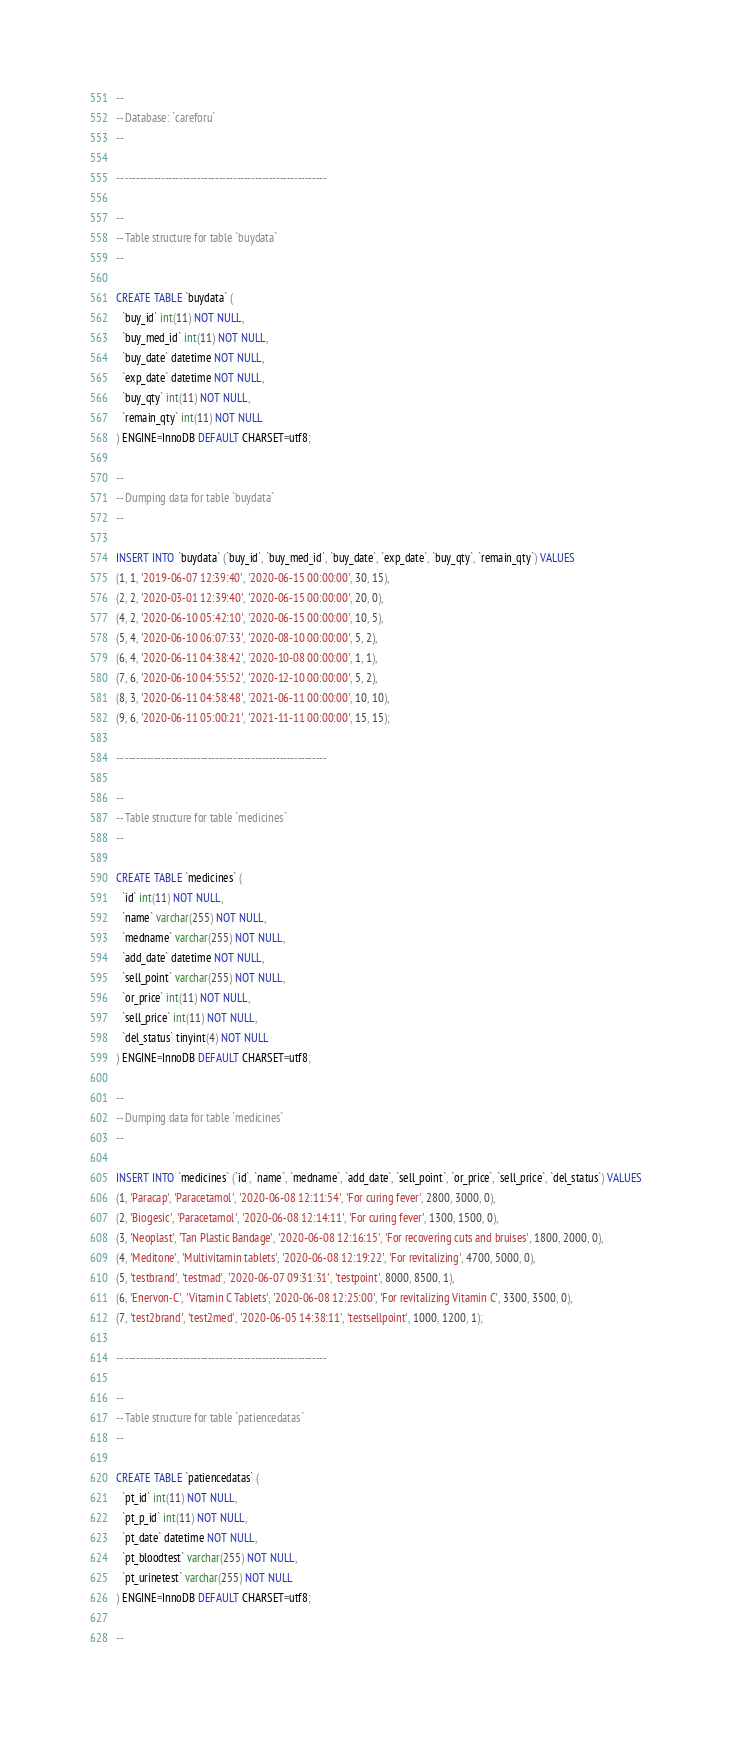<code> <loc_0><loc_0><loc_500><loc_500><_SQL_>--
-- Database: `careforu`
--

-- --------------------------------------------------------

--
-- Table structure for table `buydata`
--

CREATE TABLE `buydata` (
  `buy_id` int(11) NOT NULL,
  `buy_med_id` int(11) NOT NULL,
  `buy_date` datetime NOT NULL,
  `exp_date` datetime NOT NULL,
  `buy_qty` int(11) NOT NULL,
  `remain_qty` int(11) NOT NULL
) ENGINE=InnoDB DEFAULT CHARSET=utf8;

--
-- Dumping data for table `buydata`
--

INSERT INTO `buydata` (`buy_id`, `buy_med_id`, `buy_date`, `exp_date`, `buy_qty`, `remain_qty`) VALUES
(1, 1, '2019-06-07 12:39:40', '2020-06-15 00:00:00', 30, 15),
(2, 2, '2020-03-01 12:39:40', '2020-06-15 00:00:00', 20, 0),
(4, 2, '2020-06-10 05:42:10', '2020-06-15 00:00:00', 10, 5),
(5, 4, '2020-06-10 06:07:33', '2020-08-10 00:00:00', 5, 2),
(6, 4, '2020-06-11 04:38:42', '2020-10-08 00:00:00', 1, 1),
(7, 6, '2020-06-10 04:55:52', '2020-12-10 00:00:00', 5, 2),
(8, 3, '2020-06-11 04:58:48', '2021-06-11 00:00:00', 10, 10),
(9, 6, '2020-06-11 05:00:21', '2021-11-11 00:00:00', 15, 15);

-- --------------------------------------------------------

--
-- Table structure for table `medicines`
--

CREATE TABLE `medicines` (
  `id` int(11) NOT NULL,
  `name` varchar(255) NOT NULL,
  `medname` varchar(255) NOT NULL,
  `add_date` datetime NOT NULL,
  `sell_point` varchar(255) NOT NULL,
  `or_price` int(11) NOT NULL,
  `sell_price` int(11) NOT NULL,
  `del_status` tinyint(4) NOT NULL
) ENGINE=InnoDB DEFAULT CHARSET=utf8;

--
-- Dumping data for table `medicines`
--

INSERT INTO `medicines` (`id`, `name`, `medname`, `add_date`, `sell_point`, `or_price`, `sell_price`, `del_status`) VALUES
(1, 'Paracap', 'Paracetamol', '2020-06-08 12:11:54', 'For curing fever', 2800, 3000, 0),
(2, 'Biogesic', 'Paracetamol', '2020-06-08 12:14:11', 'For curing fever', 1300, 1500, 0),
(3, 'Neoplast', 'Tan Plastic Bandage', '2020-06-08 12:16:15', 'For recovering cuts and bruises', 1800, 2000, 0),
(4, 'Meditone', 'Multivitamin tablets', '2020-06-08 12:19:22', 'For revitalizing', 4700, 5000, 0),
(5, 'testbrand', 'testmad', '2020-06-07 09:31:31', 'testpoint', 8000, 8500, 1),
(6, 'Enervon-C', 'Vitamin C Tablets', '2020-06-08 12:25:00', 'For revitalizing Vitamin C', 3300, 3500, 0),
(7, 'test2brand', 'test2med', '2020-06-05 14:38:11', 'testsellpoint', 1000, 1200, 1);

-- --------------------------------------------------------

--
-- Table structure for table `patiencedatas`
--

CREATE TABLE `patiencedatas` (
  `pt_id` int(11) NOT NULL,
  `pt_p_id` int(11) NOT NULL,
  `pt_date` datetime NOT NULL,
  `pt_bloodtest` varchar(255) NOT NULL,
  `pt_urinetest` varchar(255) NOT NULL
) ENGINE=InnoDB DEFAULT CHARSET=utf8;

--</code> 